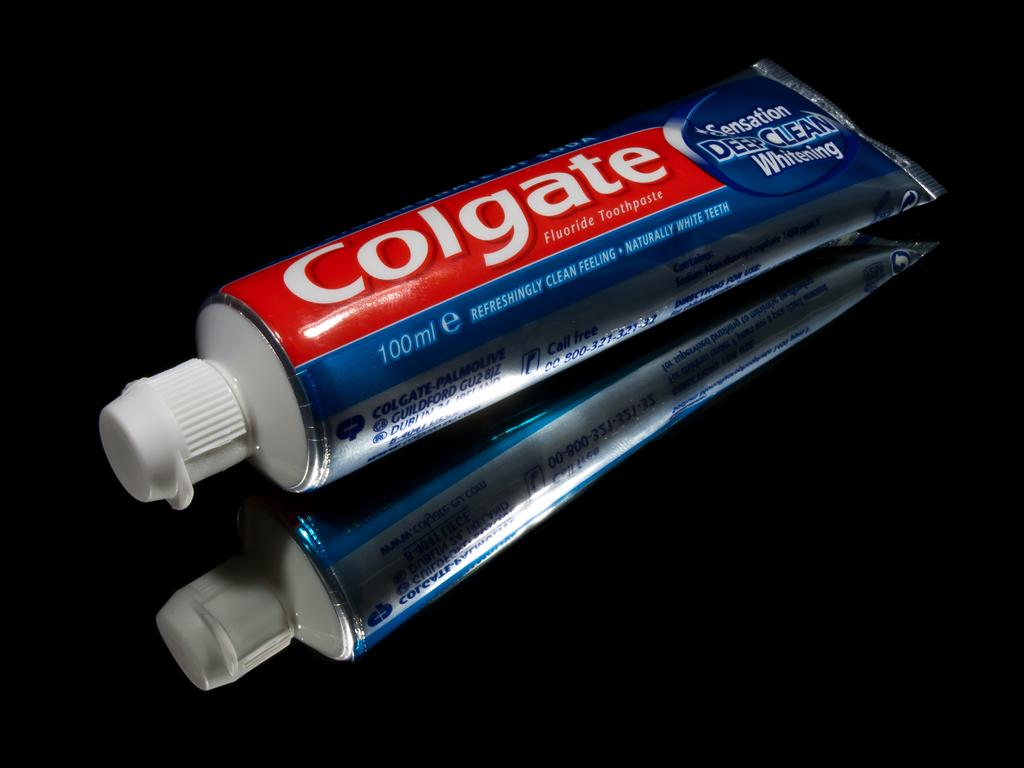<image>
Describe the image concisely. A tube of Colgate toothpaste on a black reflective surface. 